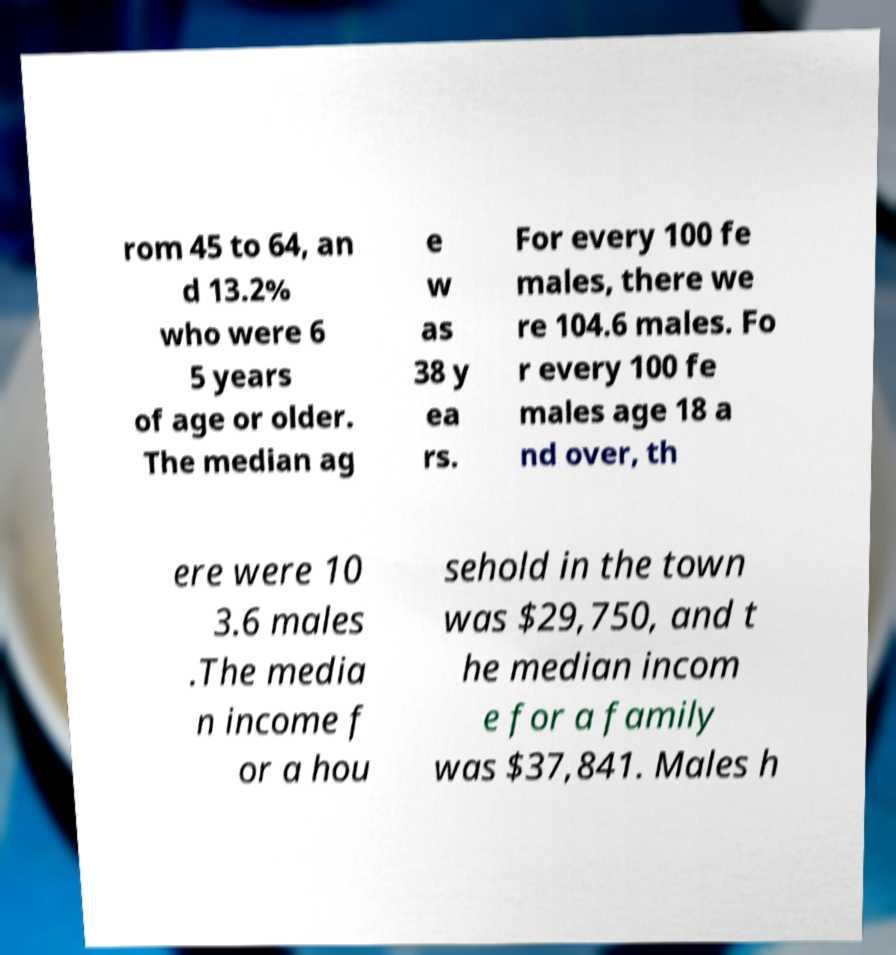For documentation purposes, I need the text within this image transcribed. Could you provide that? rom 45 to 64, an d 13.2% who were 6 5 years of age or older. The median ag e w as 38 y ea rs. For every 100 fe males, there we re 104.6 males. Fo r every 100 fe males age 18 a nd over, th ere were 10 3.6 males .The media n income f or a hou sehold in the town was $29,750, and t he median incom e for a family was $37,841. Males h 